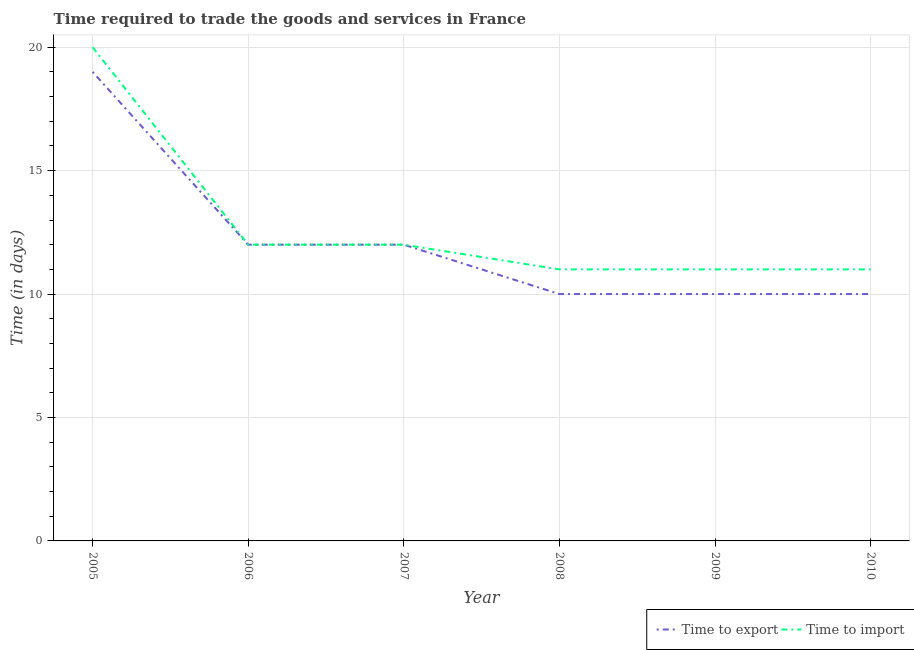Does the line corresponding to time to import intersect with the line corresponding to time to export?
Your answer should be compact. Yes. What is the time to import in 2006?
Keep it short and to the point. 12. Across all years, what is the maximum time to import?
Make the answer very short. 20. Across all years, what is the minimum time to import?
Ensure brevity in your answer.  11. In which year was the time to export minimum?
Your answer should be very brief. 2008. What is the total time to export in the graph?
Your response must be concise. 73. What is the difference between the time to import in 2006 and that in 2010?
Provide a short and direct response. 1. What is the difference between the time to import in 2007 and the time to export in 2005?
Keep it short and to the point. -7. What is the average time to import per year?
Offer a very short reply. 12.83. In the year 2006, what is the difference between the time to export and time to import?
Give a very brief answer. 0. Is the time to import in 2008 less than that in 2009?
Give a very brief answer. No. What is the difference between the highest and the lowest time to import?
Provide a succinct answer. 9. Is the sum of the time to import in 2006 and 2010 greater than the maximum time to export across all years?
Offer a terse response. Yes. Does the time to export monotonically increase over the years?
Give a very brief answer. No. Is the time to import strictly less than the time to export over the years?
Offer a very short reply. No. How many years are there in the graph?
Offer a very short reply. 6. Are the values on the major ticks of Y-axis written in scientific E-notation?
Your response must be concise. No. Does the graph contain any zero values?
Make the answer very short. No. What is the title of the graph?
Provide a short and direct response. Time required to trade the goods and services in France. What is the label or title of the Y-axis?
Your answer should be compact. Time (in days). What is the Time (in days) in Time to export in 2005?
Provide a short and direct response. 19. What is the Time (in days) of Time to import in 2005?
Provide a succinct answer. 20. What is the Time (in days) in Time to import in 2006?
Offer a very short reply. 12. What is the Time (in days) of Time to import in 2007?
Provide a short and direct response. 12. What is the Time (in days) in Time to export in 2008?
Ensure brevity in your answer.  10. What is the Time (in days) of Time to import in 2009?
Offer a very short reply. 11. What is the Time (in days) in Time to export in 2010?
Make the answer very short. 10. Across all years, what is the minimum Time (in days) in Time to export?
Offer a very short reply. 10. What is the difference between the Time (in days) of Time to import in 2005 and that in 2008?
Provide a short and direct response. 9. What is the difference between the Time (in days) of Time to import in 2005 and that in 2009?
Offer a terse response. 9. What is the difference between the Time (in days) in Time to import in 2005 and that in 2010?
Offer a terse response. 9. What is the difference between the Time (in days) of Time to export in 2006 and that in 2007?
Provide a succinct answer. 0. What is the difference between the Time (in days) of Time to import in 2006 and that in 2007?
Make the answer very short. 0. What is the difference between the Time (in days) in Time to export in 2006 and that in 2008?
Your answer should be compact. 2. What is the difference between the Time (in days) of Time to import in 2006 and that in 2008?
Ensure brevity in your answer.  1. What is the difference between the Time (in days) of Time to export in 2006 and that in 2009?
Provide a short and direct response. 2. What is the difference between the Time (in days) of Time to export in 2006 and that in 2010?
Give a very brief answer. 2. What is the difference between the Time (in days) of Time to export in 2007 and that in 2008?
Give a very brief answer. 2. What is the difference between the Time (in days) in Time to import in 2007 and that in 2008?
Provide a succinct answer. 1. What is the difference between the Time (in days) in Time to import in 2007 and that in 2009?
Ensure brevity in your answer.  1. What is the difference between the Time (in days) of Time to export in 2008 and that in 2009?
Provide a succinct answer. 0. What is the difference between the Time (in days) of Time to import in 2008 and that in 2009?
Make the answer very short. 0. What is the difference between the Time (in days) in Time to export in 2008 and that in 2010?
Ensure brevity in your answer.  0. What is the difference between the Time (in days) in Time to import in 2009 and that in 2010?
Your answer should be compact. 0. What is the difference between the Time (in days) of Time to export in 2005 and the Time (in days) of Time to import in 2006?
Your answer should be compact. 7. What is the difference between the Time (in days) in Time to export in 2005 and the Time (in days) in Time to import in 2007?
Keep it short and to the point. 7. What is the difference between the Time (in days) in Time to export in 2005 and the Time (in days) in Time to import in 2010?
Provide a short and direct response. 8. What is the difference between the Time (in days) in Time to export in 2007 and the Time (in days) in Time to import in 2008?
Offer a terse response. 1. What is the average Time (in days) of Time to export per year?
Offer a very short reply. 12.17. What is the average Time (in days) in Time to import per year?
Make the answer very short. 12.83. In the year 2005, what is the difference between the Time (in days) of Time to export and Time (in days) of Time to import?
Ensure brevity in your answer.  -1. In the year 2006, what is the difference between the Time (in days) in Time to export and Time (in days) in Time to import?
Your answer should be very brief. 0. In the year 2007, what is the difference between the Time (in days) in Time to export and Time (in days) in Time to import?
Your response must be concise. 0. In the year 2009, what is the difference between the Time (in days) of Time to export and Time (in days) of Time to import?
Your answer should be compact. -1. What is the ratio of the Time (in days) in Time to export in 2005 to that in 2006?
Your answer should be very brief. 1.58. What is the ratio of the Time (in days) of Time to export in 2005 to that in 2007?
Provide a short and direct response. 1.58. What is the ratio of the Time (in days) in Time to import in 2005 to that in 2007?
Your response must be concise. 1.67. What is the ratio of the Time (in days) in Time to export in 2005 to that in 2008?
Provide a short and direct response. 1.9. What is the ratio of the Time (in days) of Time to import in 2005 to that in 2008?
Your response must be concise. 1.82. What is the ratio of the Time (in days) of Time to export in 2005 to that in 2009?
Give a very brief answer. 1.9. What is the ratio of the Time (in days) of Time to import in 2005 to that in 2009?
Provide a short and direct response. 1.82. What is the ratio of the Time (in days) of Time to export in 2005 to that in 2010?
Your response must be concise. 1.9. What is the ratio of the Time (in days) in Time to import in 2005 to that in 2010?
Make the answer very short. 1.82. What is the ratio of the Time (in days) of Time to export in 2006 to that in 2008?
Your answer should be very brief. 1.2. What is the ratio of the Time (in days) of Time to export in 2006 to that in 2010?
Make the answer very short. 1.2. What is the ratio of the Time (in days) of Time to export in 2007 to that in 2008?
Give a very brief answer. 1.2. What is the ratio of the Time (in days) of Time to import in 2007 to that in 2008?
Your answer should be very brief. 1.09. What is the ratio of the Time (in days) of Time to export in 2008 to that in 2010?
Ensure brevity in your answer.  1. What is the ratio of the Time (in days) in Time to export in 2009 to that in 2010?
Provide a short and direct response. 1. What is the ratio of the Time (in days) in Time to import in 2009 to that in 2010?
Make the answer very short. 1. What is the difference between the highest and the lowest Time (in days) in Time to export?
Keep it short and to the point. 9. What is the difference between the highest and the lowest Time (in days) of Time to import?
Your answer should be compact. 9. 